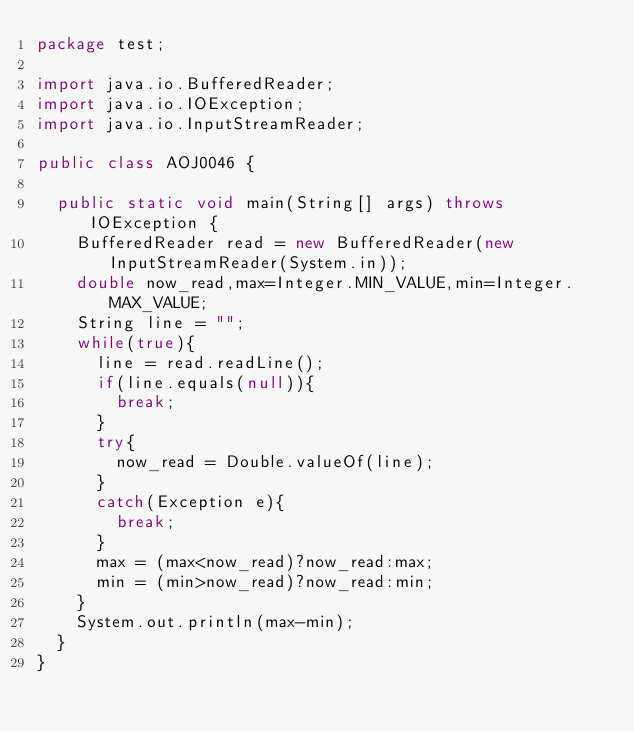<code> <loc_0><loc_0><loc_500><loc_500><_Java_>package test;

import java.io.BufferedReader;
import java.io.IOException;
import java.io.InputStreamReader;

public class AOJ0046 {

	public static void main(String[] args) throws IOException {
		BufferedReader read = new BufferedReader(new InputStreamReader(System.in));
		double now_read,max=Integer.MIN_VALUE,min=Integer.MAX_VALUE;
		String line = "";
		while(true){
			line = read.readLine();
			if(line.equals(null)){
				break;
			}
			try{
				now_read = Double.valueOf(line);
			}
			catch(Exception e){
				break;
			}
			max = (max<now_read)?now_read:max;
			min = (min>now_read)?now_read:min;
		}
		System.out.println(max-min);
	}
}</code> 